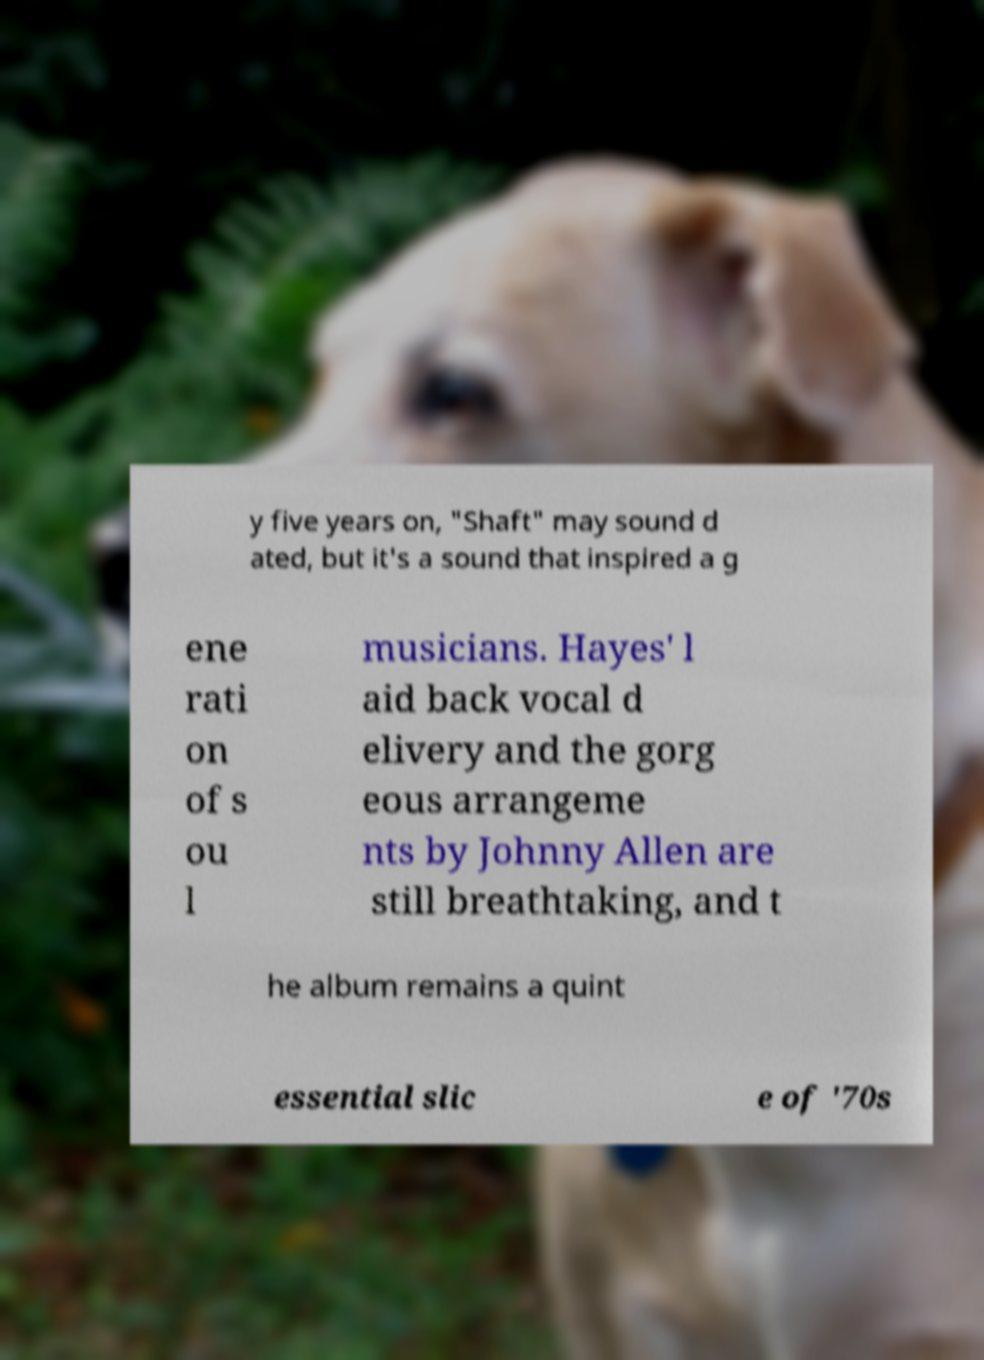Please identify and transcribe the text found in this image. y five years on, "Shaft" may sound d ated, but it's a sound that inspired a g ene rati on of s ou l musicians. Hayes' l aid back vocal d elivery and the gorg eous arrangeme nts by Johnny Allen are still breathtaking, and t he album remains a quint essential slic e of '70s 